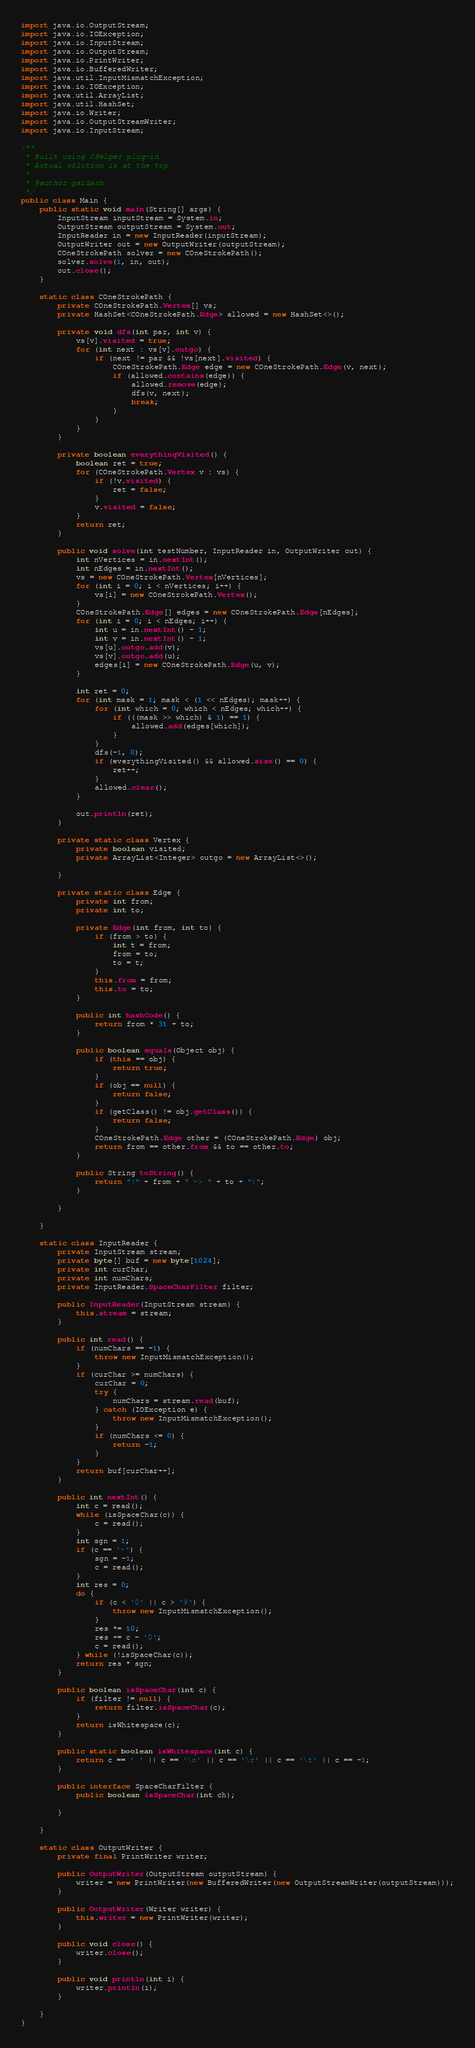<code> <loc_0><loc_0><loc_500><loc_500><_Java_>import java.io.OutputStream;
import java.io.IOException;
import java.io.InputStream;
import java.io.OutputStream;
import java.io.PrintWriter;
import java.io.BufferedWriter;
import java.util.InputMismatchException;
import java.io.IOException;
import java.util.ArrayList;
import java.util.HashSet;
import java.io.Writer;
import java.io.OutputStreamWriter;
import java.io.InputStream;

/**
 * Built using CHelper plug-in
 * Actual solution is at the top
 *
 * @author gaidash
 */
public class Main {
    public static void main(String[] args) {
        InputStream inputStream = System.in;
        OutputStream outputStream = System.out;
        InputReader in = new InputReader(inputStream);
        OutputWriter out = new OutputWriter(outputStream);
        COneStrokePath solver = new COneStrokePath();
        solver.solve(1, in, out);
        out.close();
    }

    static class COneStrokePath {
        private COneStrokePath.Vertex[] vs;
        private HashSet<COneStrokePath.Edge> allowed = new HashSet<>();

        private void dfs(int par, int v) {
            vs[v].visited = true;
            for (int next : vs[v].outgo) {
                if (next != par && !vs[next].visited) {
                    COneStrokePath.Edge edge = new COneStrokePath.Edge(v, next);
                    if (allowed.contains(edge)) {
                        allowed.remove(edge);
                        dfs(v, next);
                        break;
                    }
                }
            }
        }

        private boolean everythingVisited() {
            boolean ret = true;
            for (COneStrokePath.Vertex v : vs) {
                if (!v.visited) {
                    ret = false;
                }
                v.visited = false;
            }
            return ret;
        }

        public void solve(int testNumber, InputReader in, OutputWriter out) {
            int nVertices = in.nextInt();
            int nEdges = in.nextInt();
            vs = new COneStrokePath.Vertex[nVertices];
            for (int i = 0; i < nVertices; i++) {
                vs[i] = new COneStrokePath.Vertex();
            }
            COneStrokePath.Edge[] edges = new COneStrokePath.Edge[nEdges];
            for (int i = 0; i < nEdges; i++) {
                int u = in.nextInt() - 1;
                int v = in.nextInt() - 1;
                vs[u].outgo.add(v);
                vs[v].outgo.add(u);
                edges[i] = new COneStrokePath.Edge(u, v);
            }

            int ret = 0;
            for (int mask = 1; mask < (1 << nEdges); mask++) {
                for (int which = 0; which < nEdges; which++) {
                    if (((mask >> which) & 1) == 1) {
                        allowed.add(edges[which]);
                    }
                }
                dfs(-1, 0);
                if (everythingVisited() && allowed.size() == 0) {
                    ret++;
                }
                allowed.clear();
            }

            out.println(ret);
        }

        private static class Vertex {
            private boolean visited;
            private ArrayList<Integer> outgo = new ArrayList<>();

        }

        private static class Edge {
            private int from;
            private int to;

            private Edge(int from, int to) {
                if (from > to) {
                    int t = from;
                    from = to;
                    to = t;
                }
                this.from = from;
                this.to = to;
            }

            public int hashCode() {
                return from * 31 + to;
            }

            public boolean equals(Object obj) {
                if (this == obj) {
                    return true;
                }
                if (obj == null) {
                    return false;
                }
                if (getClass() != obj.getClass()) {
                    return false;
                }
                COneStrokePath.Edge other = (COneStrokePath.Edge) obj;
                return from == other.from && to == other.to;
            }

            public String toString() {
                return "(" + from + " -> " + to + ")";
            }

        }

    }

    static class InputReader {
        private InputStream stream;
        private byte[] buf = new byte[1024];
        private int curChar;
        private int numChars;
        private InputReader.SpaceCharFilter filter;

        public InputReader(InputStream stream) {
            this.stream = stream;
        }

        public int read() {
            if (numChars == -1) {
                throw new InputMismatchException();
            }
            if (curChar >= numChars) {
                curChar = 0;
                try {
                    numChars = stream.read(buf);
                } catch (IOException e) {
                    throw new InputMismatchException();
                }
                if (numChars <= 0) {
                    return -1;
                }
            }
            return buf[curChar++];
        }

        public int nextInt() {
            int c = read();
            while (isSpaceChar(c)) {
                c = read();
            }
            int sgn = 1;
            if (c == '-') {
                sgn = -1;
                c = read();
            }
            int res = 0;
            do {
                if (c < '0' || c > '9') {
                    throw new InputMismatchException();
                }
                res *= 10;
                res += c - '0';
                c = read();
            } while (!isSpaceChar(c));
            return res * sgn;
        }

        public boolean isSpaceChar(int c) {
            if (filter != null) {
                return filter.isSpaceChar(c);
            }
            return isWhitespace(c);
        }

        public static boolean isWhitespace(int c) {
            return c == ' ' || c == '\n' || c == '\r' || c == '\t' || c == -1;
        }

        public interface SpaceCharFilter {
            public boolean isSpaceChar(int ch);

        }

    }

    static class OutputWriter {
        private final PrintWriter writer;

        public OutputWriter(OutputStream outputStream) {
            writer = new PrintWriter(new BufferedWriter(new OutputStreamWriter(outputStream)));
        }

        public OutputWriter(Writer writer) {
            this.writer = new PrintWriter(writer);
        }

        public void close() {
            writer.close();
        }

        public void println(int i) {
            writer.println(i);
        }

    }
}

</code> 